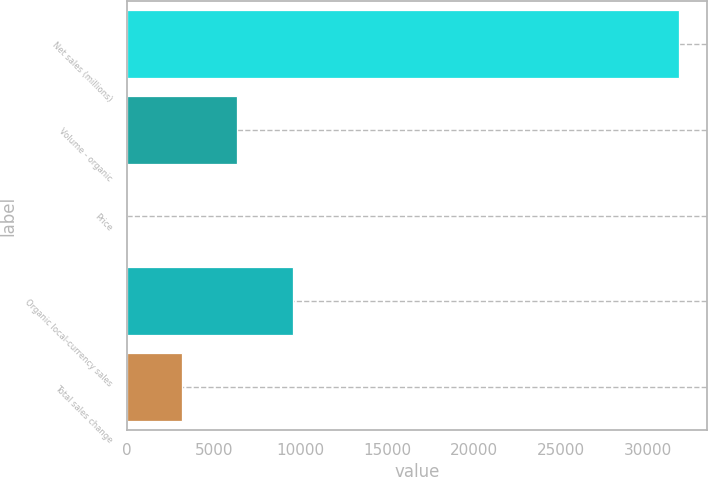Convert chart to OTSL. <chart><loc_0><loc_0><loc_500><loc_500><bar_chart><fcel>Net sales (millions)<fcel>Volume - organic<fcel>Price<fcel>Organic local-currency sales<fcel>Total sales change<nl><fcel>31821<fcel>6365<fcel>1<fcel>9547<fcel>3183<nl></chart> 